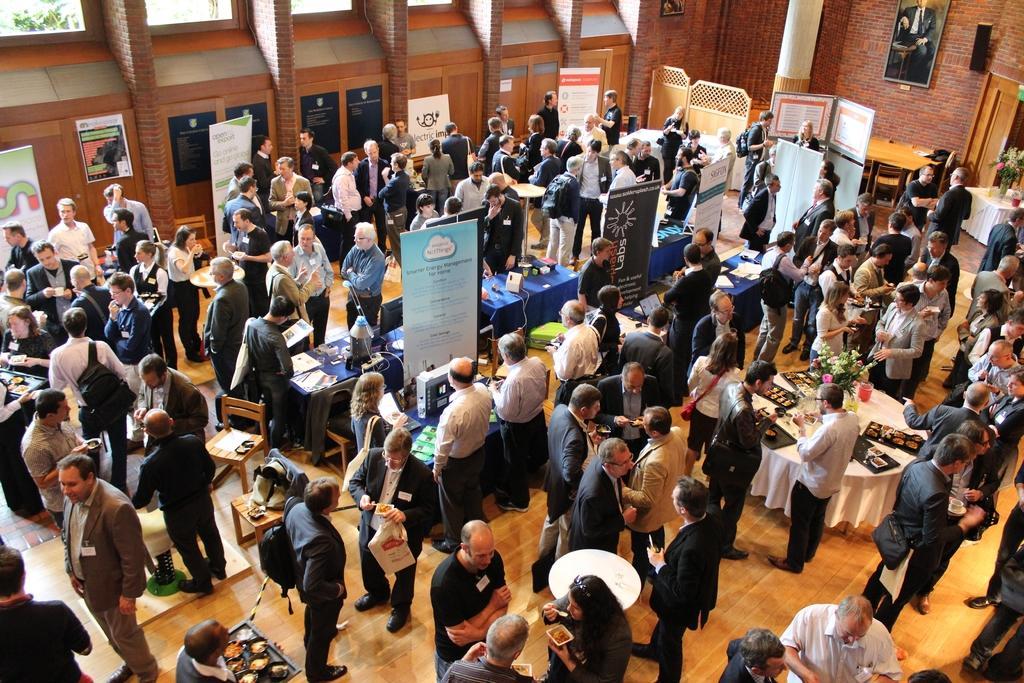Describe this image in one or two sentences. In this image we can see a group of people standing on the floor. In that some are holding the plates containing food in it. We can also see the tables containing the bouquets, food in the trays, devices and some objects which are placed on them. Besides we can see some banners, frames on a wall, a speaker box, a pillar, windows and a door. 